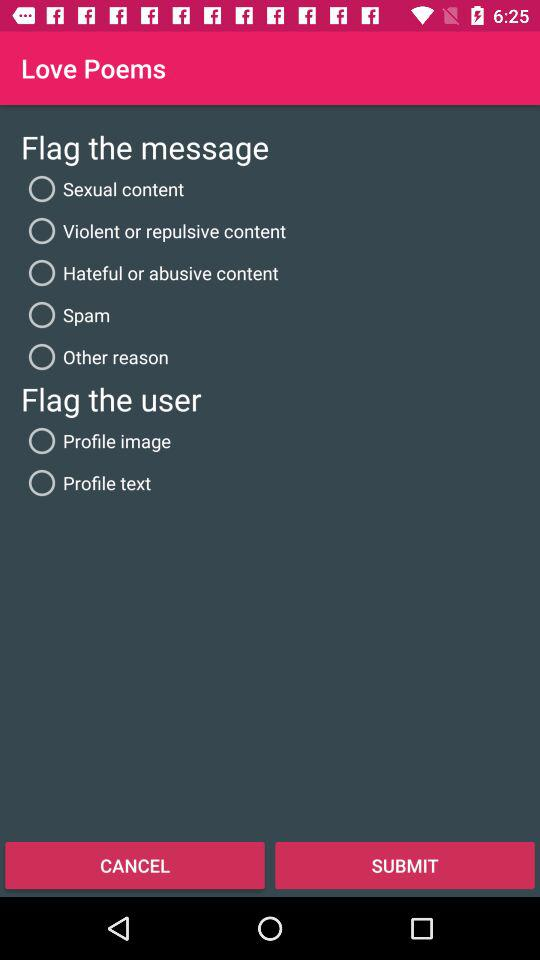How many reasons are there to flag a message?
Answer the question using a single word or phrase. 5 